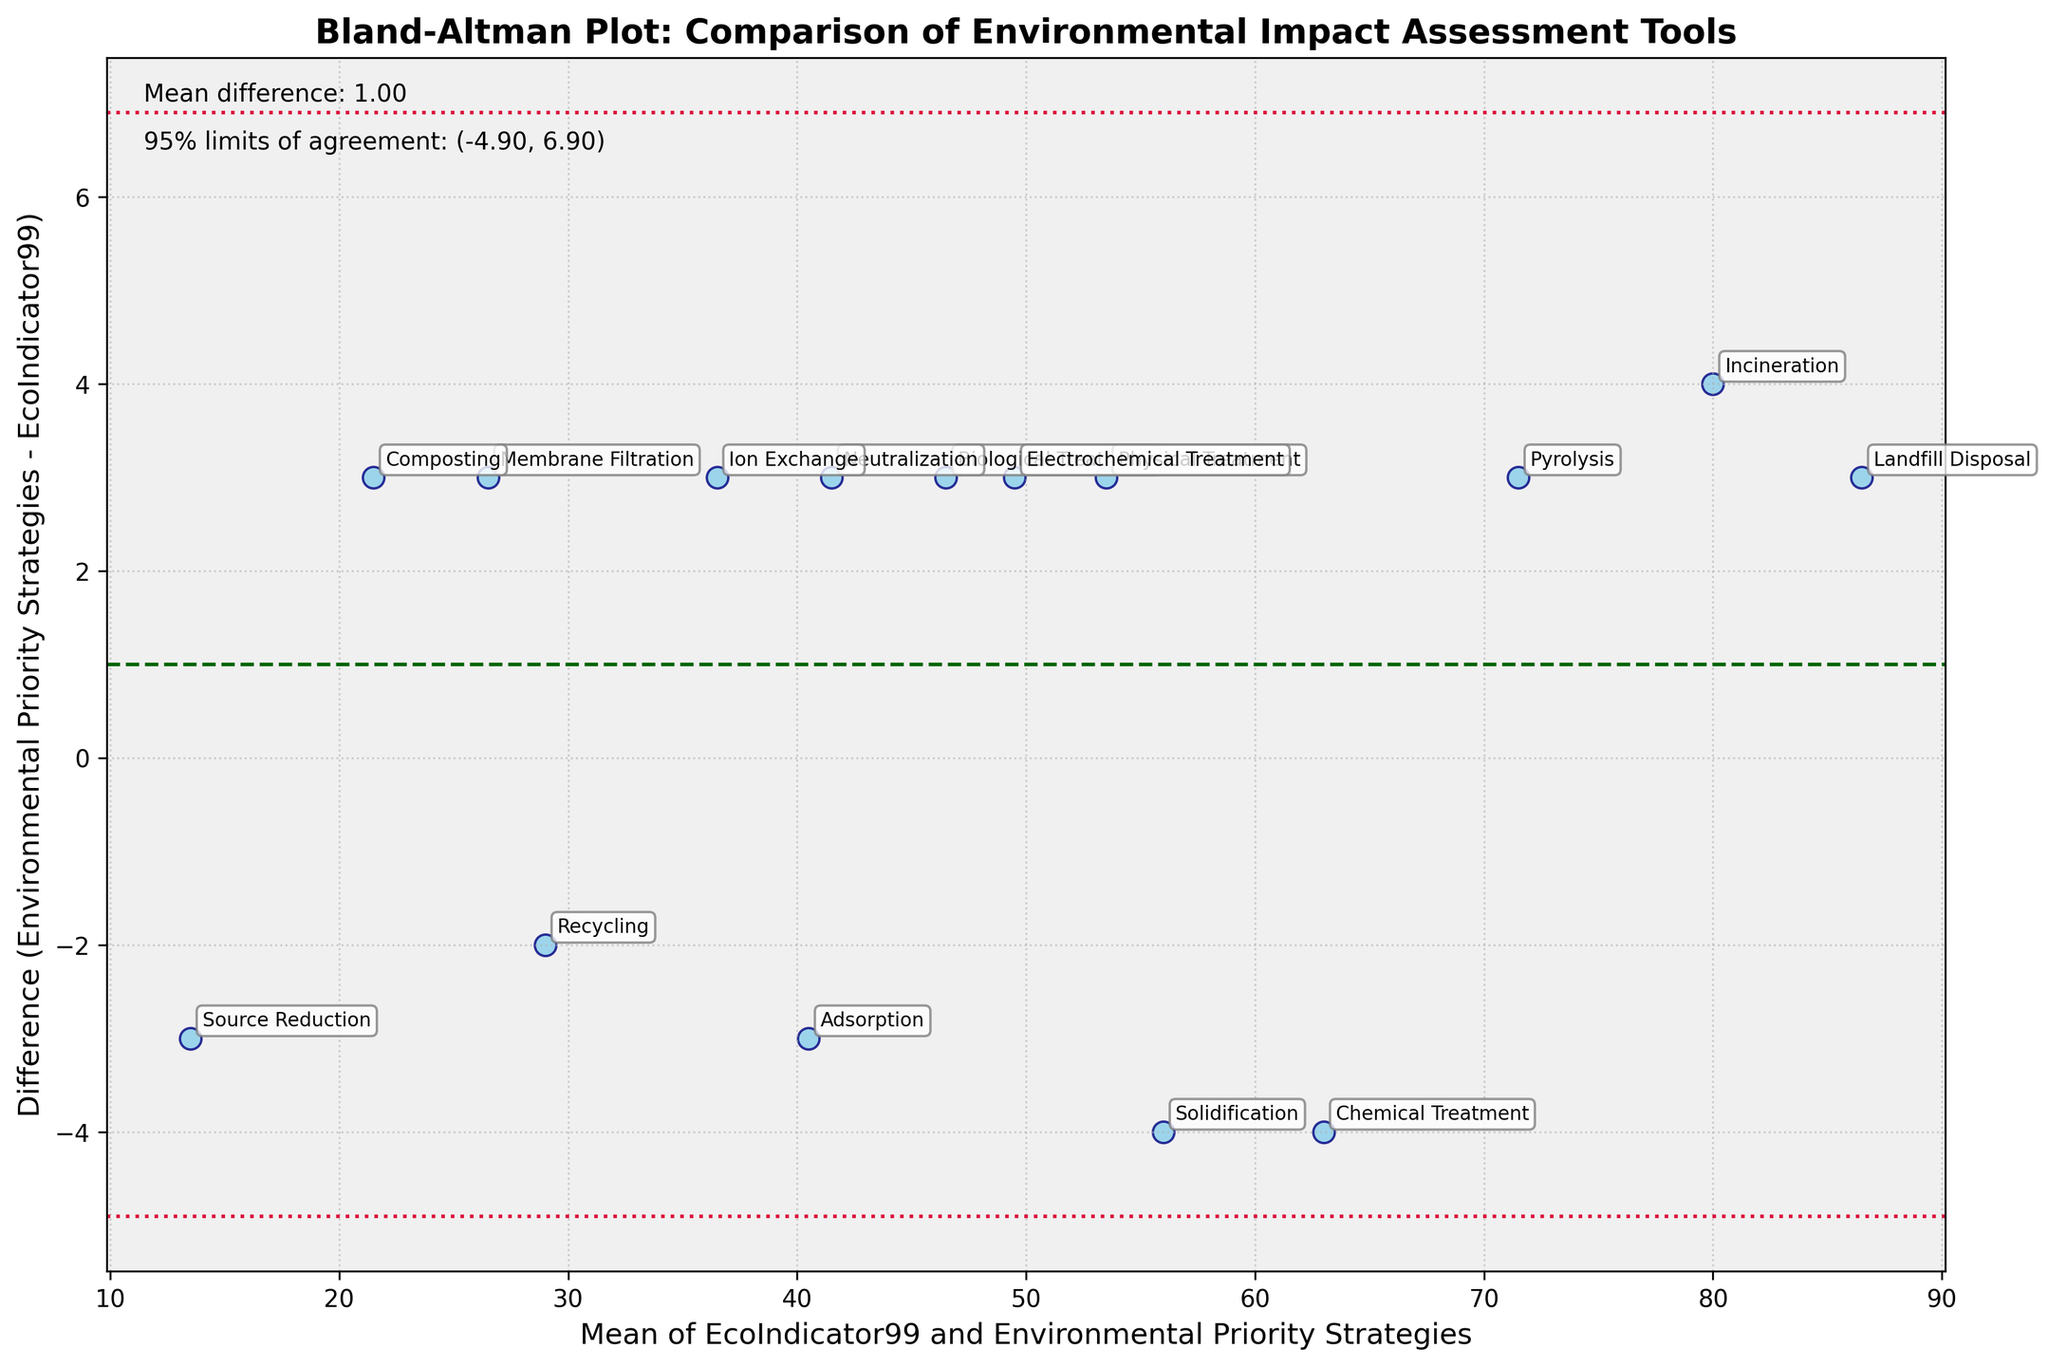How many data points are plotted in the Bland-Altman plot? Count the number of individual points on the plot. There should be one for each method mentioned in the data, which sums up to 15.
Answer: 15 What does the dashed horizontal line on the plot represent? The dashed horizontal line indicates the mean difference between the two measurement tools, EcoIndicator99 and Environmental Priority Strategies.
Answer: Mean difference Which method has the maximum mean of the two assessment tools? Locate the data point positioned furthest to the right on the plot, representing the highest mean value. It corresponds to the Landfill Disposal method.
Answer: Landfill Disposal For which method is the difference between the two assessment tools the largest? Identify the point with the maximum vertical distance from the zero difference line. This point corresponds to Landfill Disposal, which shows the greatest positive difference.
Answer: Landfill Disposal What are the values of the 95% limits of agreement? Look at the horizontal lines marked by dotted lines; they signify the range within which 95% of differences (Environmental Priority Strategies - EcoIndicator99) lie. The values are calculated as (mean_difference - 1.96*standard_deviation) and (mean_difference + 1.96*standard_deviation). Based on the plot, the values are approximately (-2.56, 7.56).
Answer: (-2.56, 7.56) Which methods fall within the 95% limits of agreement? Identify all data points that fall between the top (7.56) and bottom (-2.56) dotted lines. Every point except Landfill Disposal is within this range.
Answer: All except Landfill Disposal What is the mean value of the two metrics for Neutralization? Calculate the mean of EcoIndicator99 and Environmental Priority Strategies for Neutralization. The mean is (40+43)/2 = 41.5.
Answer: 41.5 Which method has a negative difference between the two assessment tools? Identify the data points below the zero difference line. The methods include Chemical Treatment, Recycling, Solidification, Ion Exchange, Adsorption, Membrane Filtration, Composting, and Source Reduction.
Answer: Chemical Treatment, Recycling, Solidification, Ion Exchange, Adsorption, Membrane Filtration, Composting, Source Reduction What trend, if any, do you observe in the differences as the mean increases? Look at the spread and pattern of the data points as you move from left to right on the plot. Generally, there is an increasing trend, meaning differences tend to be larger at higher mean values.
Answer: Increasing trend 